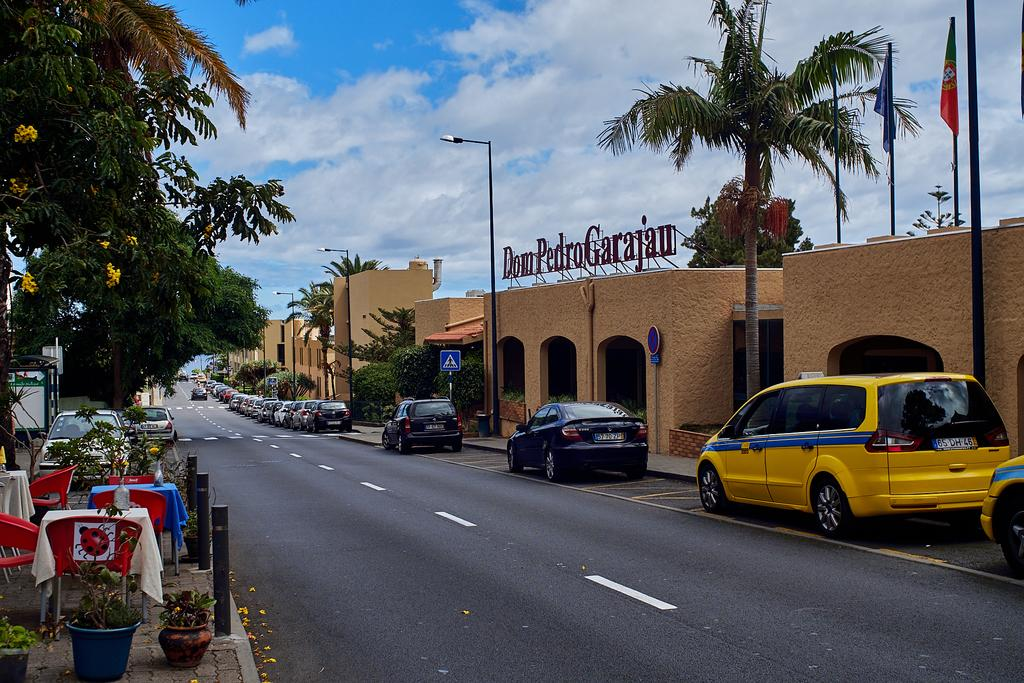<image>
Present a compact description of the photo's key features. A street scene with a building bearing a sign reading Dom Pedro Garajan 